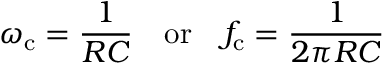<formula> <loc_0><loc_0><loc_500><loc_500>\omega _ { c } = { \frac { 1 } { R C } } \quad o r \quad f _ { c } = { \frac { 1 } { 2 \pi R C } }</formula> 